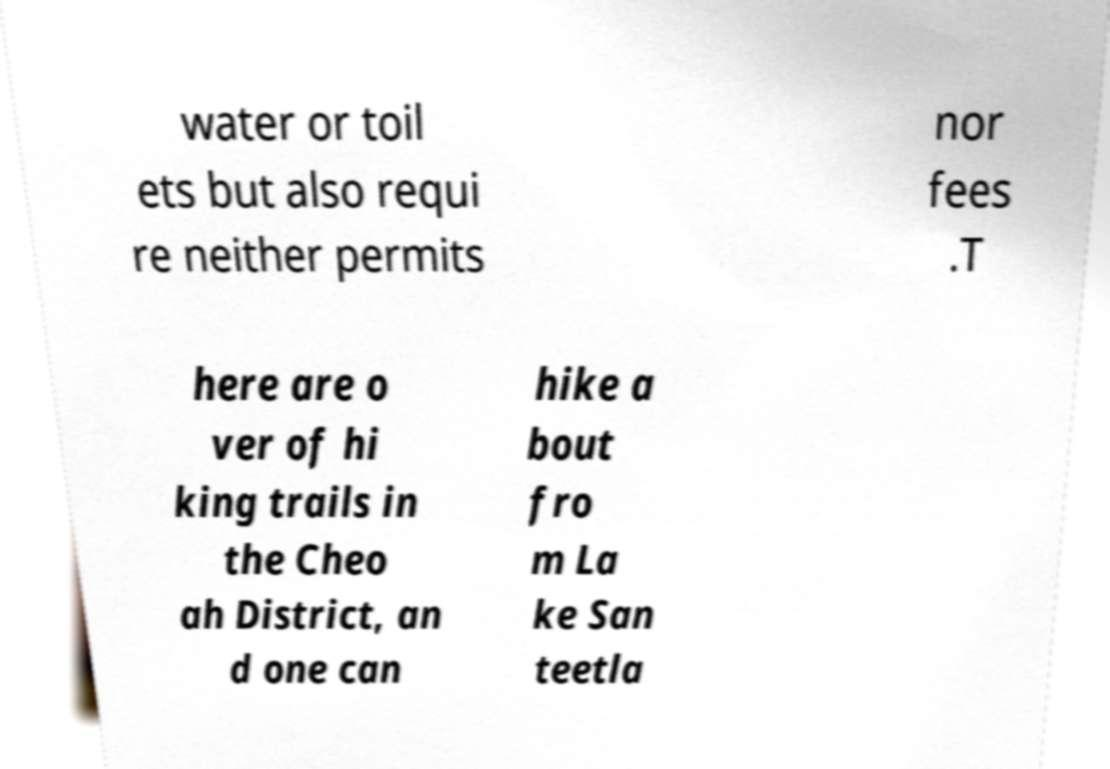For documentation purposes, I need the text within this image transcribed. Could you provide that? water or toil ets but also requi re neither permits nor fees .T here are o ver of hi king trails in the Cheo ah District, an d one can hike a bout fro m La ke San teetla 